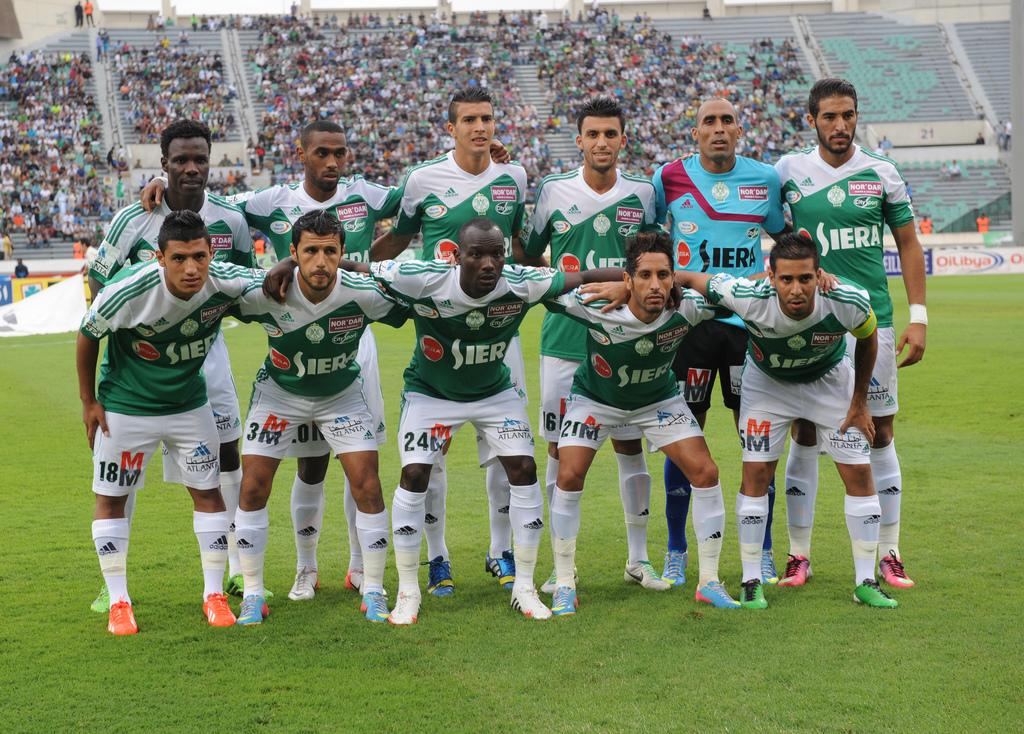Provide a one-sentence caption for the provided image. The soccer team is sponsored by a company called Siera. 